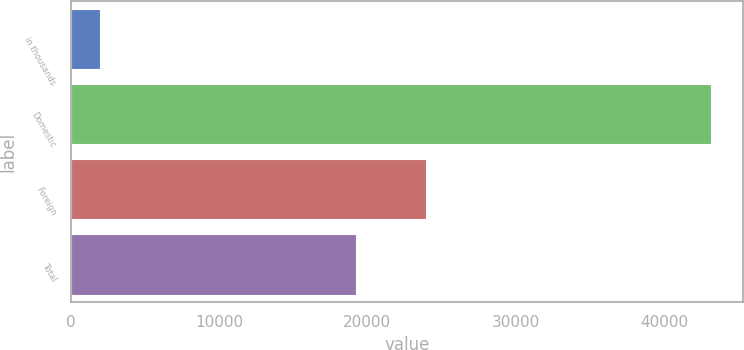Convert chart to OTSL. <chart><loc_0><loc_0><loc_500><loc_500><bar_chart><fcel>in thousands<fcel>Domestic<fcel>Foreign<fcel>Total<nl><fcel>2009<fcel>43180<fcel>23959<fcel>19221<nl></chart> 